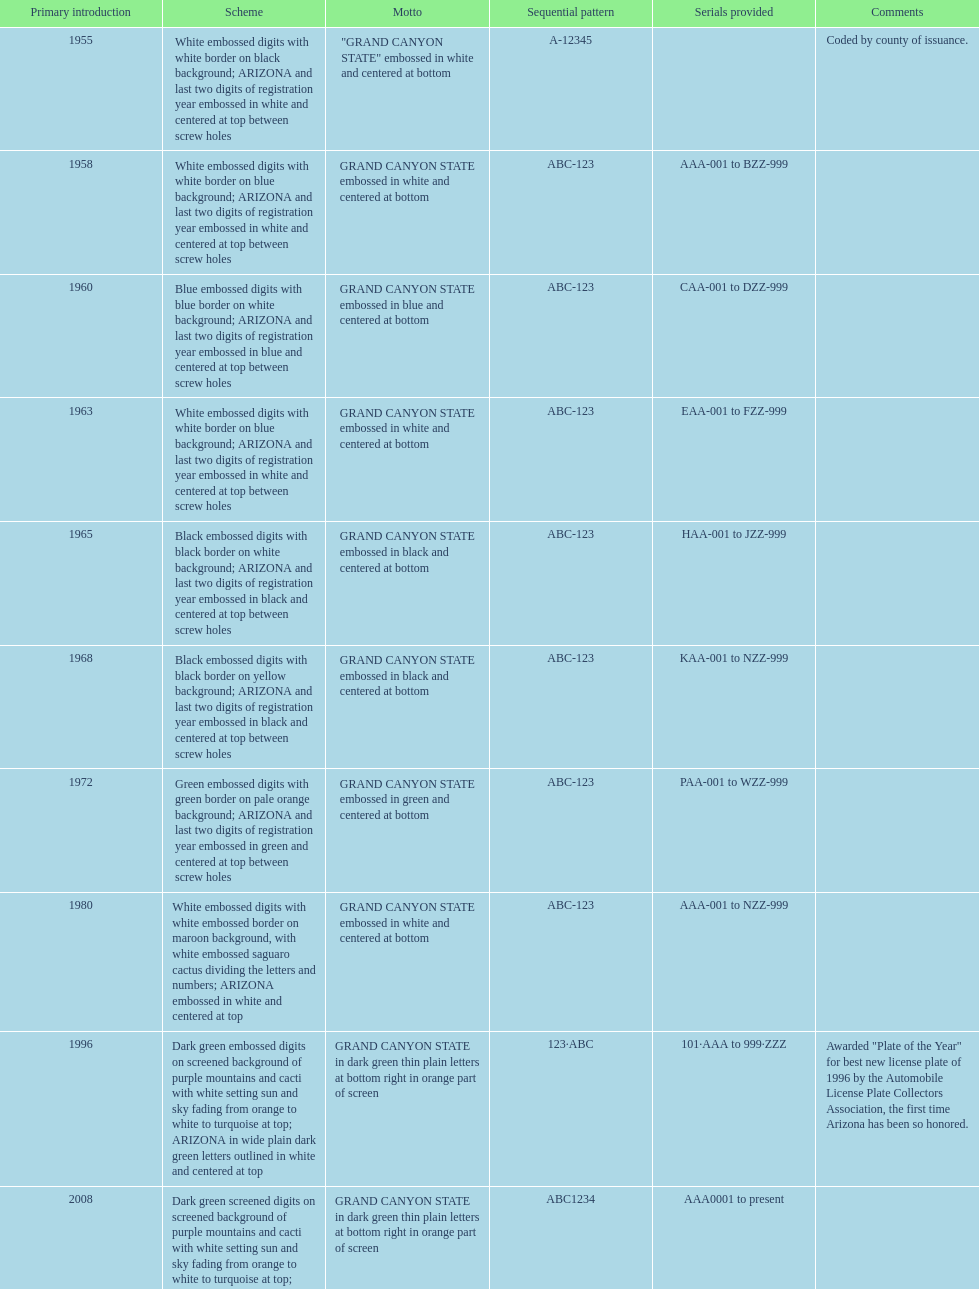Name the year of the license plate that has the largest amount of alphanumeric digits. 2008. Could you help me parse every detail presented in this table? {'header': ['Primary introduction', 'Scheme', 'Motto', 'Sequential pattern', 'Serials provided', 'Comments'], 'rows': [['1955', 'White embossed digits with white border on black background; ARIZONA and last two digits of registration year embossed in white and centered at top between screw holes', '"GRAND CANYON STATE" embossed in white and centered at bottom', 'A-12345', '', 'Coded by county of issuance.'], ['1958', 'White embossed digits with white border on blue background; ARIZONA and last two digits of registration year embossed in white and centered at top between screw holes', 'GRAND CANYON STATE embossed in white and centered at bottom', 'ABC-123', 'AAA-001 to BZZ-999', ''], ['1960', 'Blue embossed digits with blue border on white background; ARIZONA and last two digits of registration year embossed in blue and centered at top between screw holes', 'GRAND CANYON STATE embossed in blue and centered at bottom', 'ABC-123', 'CAA-001 to DZZ-999', ''], ['1963', 'White embossed digits with white border on blue background; ARIZONA and last two digits of registration year embossed in white and centered at top between screw holes', 'GRAND CANYON STATE embossed in white and centered at bottom', 'ABC-123', 'EAA-001 to FZZ-999', ''], ['1965', 'Black embossed digits with black border on white background; ARIZONA and last two digits of registration year embossed in black and centered at top between screw holes', 'GRAND CANYON STATE embossed in black and centered at bottom', 'ABC-123', 'HAA-001 to JZZ-999', ''], ['1968', 'Black embossed digits with black border on yellow background; ARIZONA and last two digits of registration year embossed in black and centered at top between screw holes', 'GRAND CANYON STATE embossed in black and centered at bottom', 'ABC-123', 'KAA-001 to NZZ-999', ''], ['1972', 'Green embossed digits with green border on pale orange background; ARIZONA and last two digits of registration year embossed in green and centered at top between screw holes', 'GRAND CANYON STATE embossed in green and centered at bottom', 'ABC-123', 'PAA-001 to WZZ-999', ''], ['1980', 'White embossed digits with white embossed border on maroon background, with white embossed saguaro cactus dividing the letters and numbers; ARIZONA embossed in white and centered at top', 'GRAND CANYON STATE embossed in white and centered at bottom', 'ABC-123', 'AAA-001 to NZZ-999', ''], ['1996', 'Dark green embossed digits on screened background of purple mountains and cacti with white setting sun and sky fading from orange to white to turquoise at top; ARIZONA in wide plain dark green letters outlined in white and centered at top', 'GRAND CANYON STATE in dark green thin plain letters at bottom right in orange part of screen', '123·ABC', '101·AAA to 999·ZZZ', 'Awarded "Plate of the Year" for best new license plate of 1996 by the Automobile License Plate Collectors Association, the first time Arizona has been so honored.'], ['2008', 'Dark green screened digits on screened background of purple mountains and cacti with white setting sun and sky fading from orange to white to turquoise at top; ARIZONA in wide plain dark green letters outlined in white and centered at top; security stripe through center of plate', 'GRAND CANYON STATE in dark green thin plain letters at bottom right in orange part of screen', 'ABC1234', 'AAA0001 to present', '']]} 